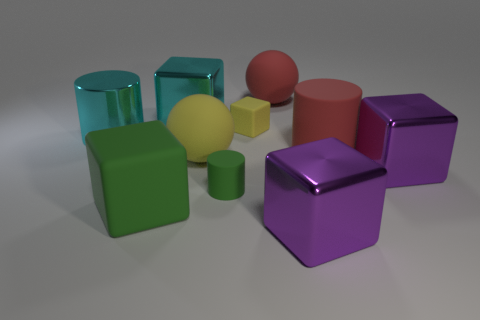The red matte object that is the same shape as the big yellow thing is what size?
Your answer should be compact. Large. What number of big gray cylinders are there?
Ensure brevity in your answer.  0. How many large rubber objects are in front of the green cylinder and behind the cyan metal cube?
Offer a very short reply. 0. Is there a cyan block that has the same material as the red ball?
Provide a short and direct response. No. What material is the cylinder on the left side of the rubber block that is in front of the small green object?
Make the answer very short. Metal. Are there an equal number of large matte objects that are in front of the big yellow matte thing and yellow rubber blocks that are on the left side of the green cube?
Your response must be concise. No. Do the small green matte object and the big green object have the same shape?
Your answer should be very brief. No. What is the big block that is both in front of the big yellow rubber sphere and behind the tiny cylinder made of?
Your response must be concise. Metal. How many large green matte objects are the same shape as the large yellow object?
Offer a very short reply. 0. How big is the shiny block that is left of the matte cylinder that is in front of the yellow sphere on the left side of the green cylinder?
Give a very brief answer. Large. 